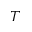<formula> <loc_0><loc_0><loc_500><loc_500>^ { T }</formula> 